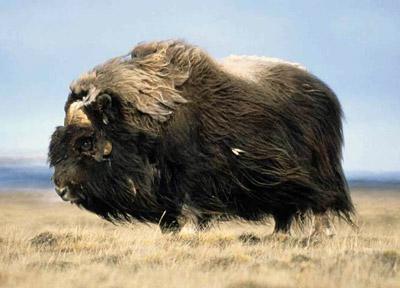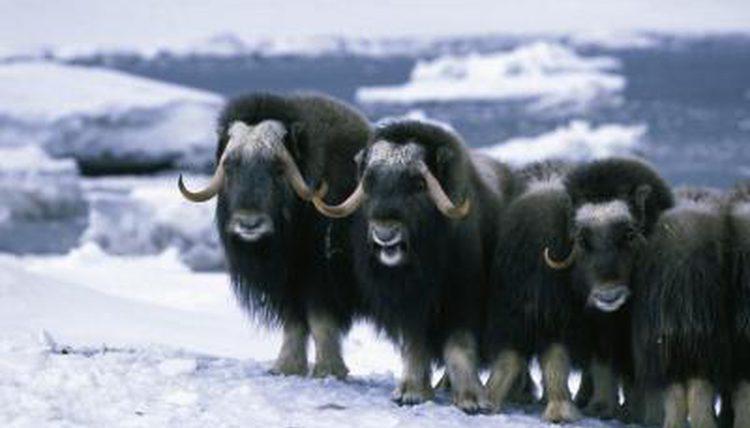The first image is the image on the left, the second image is the image on the right. Considering the images on both sides, is "In the left photo, there is only one buffalo." valid? Answer yes or no. Yes. The first image is the image on the left, the second image is the image on the right. Examine the images to the left and right. Is the description "There are 8 or more buffalo present in the snow." accurate? Answer yes or no. No. 